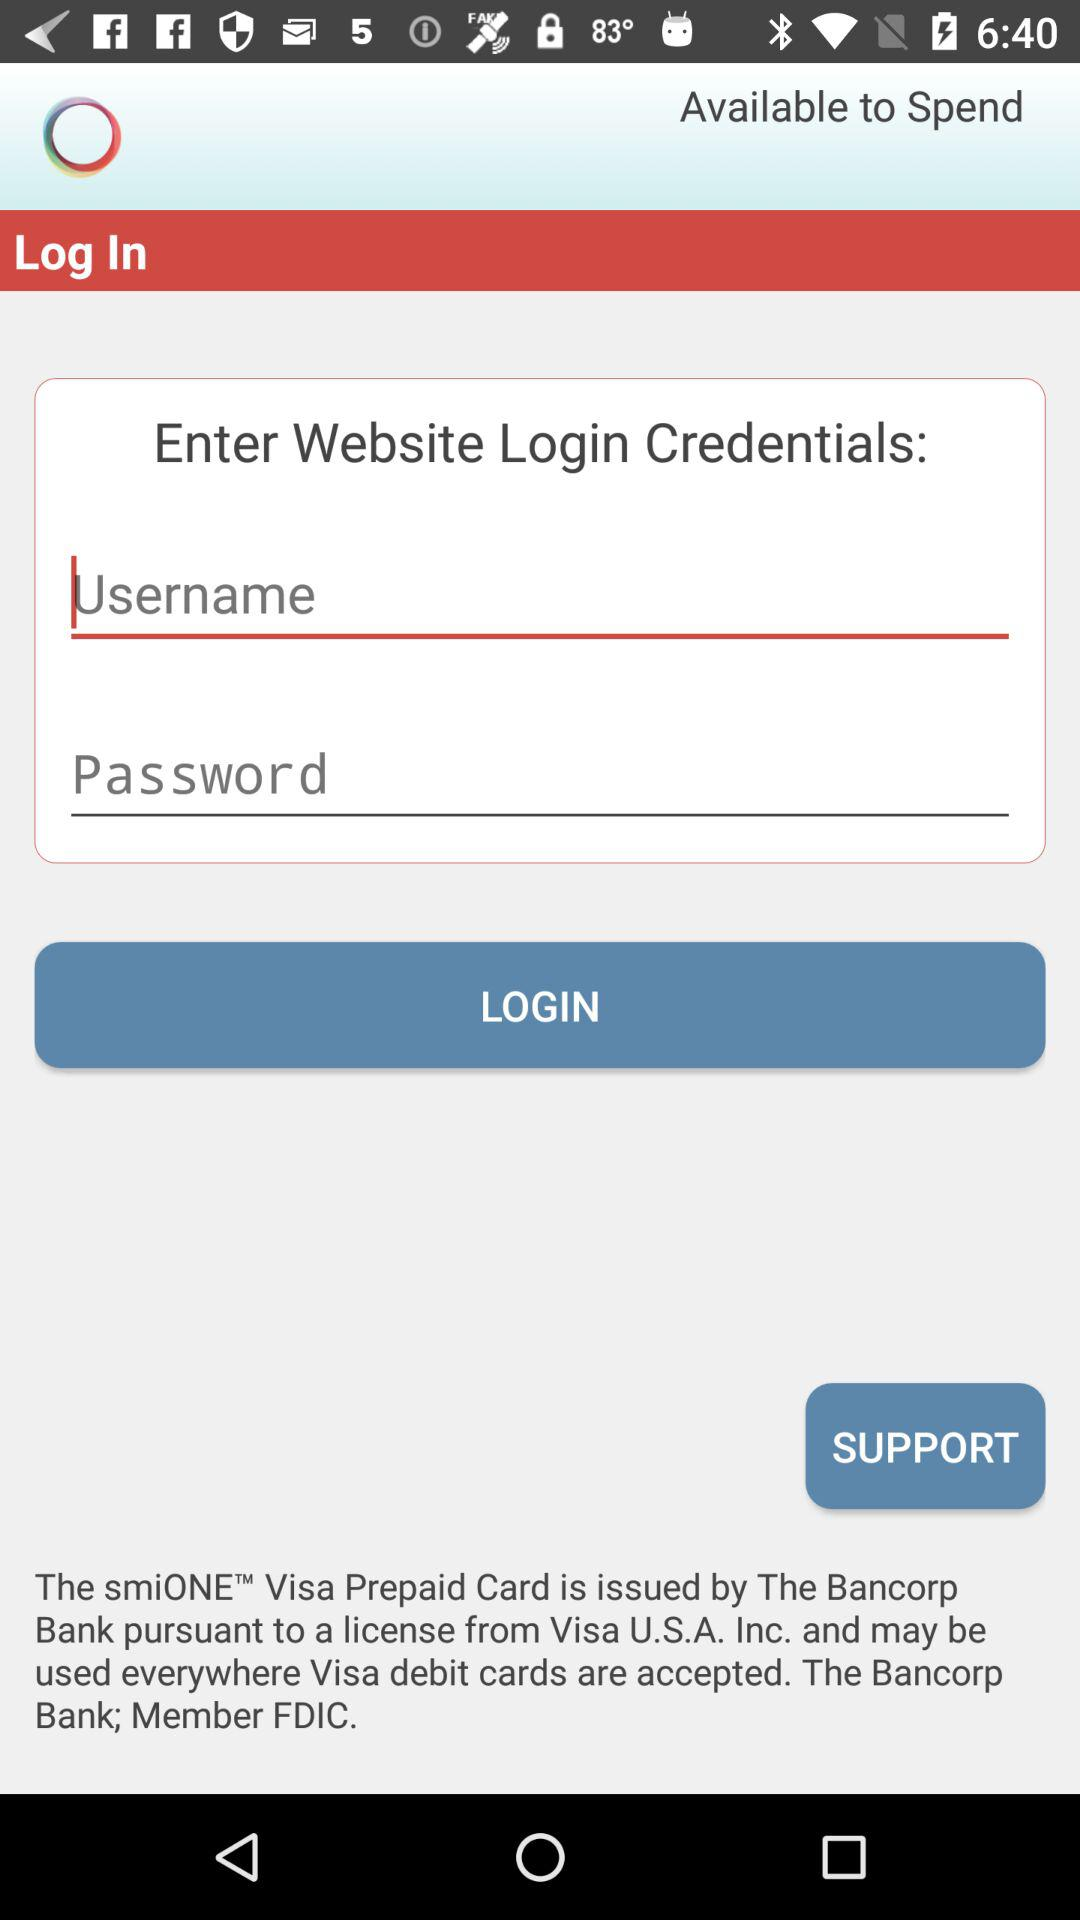What are the requirements to get a login?
When the provided information is insufficient, respond with <no answer>. <no answer> 